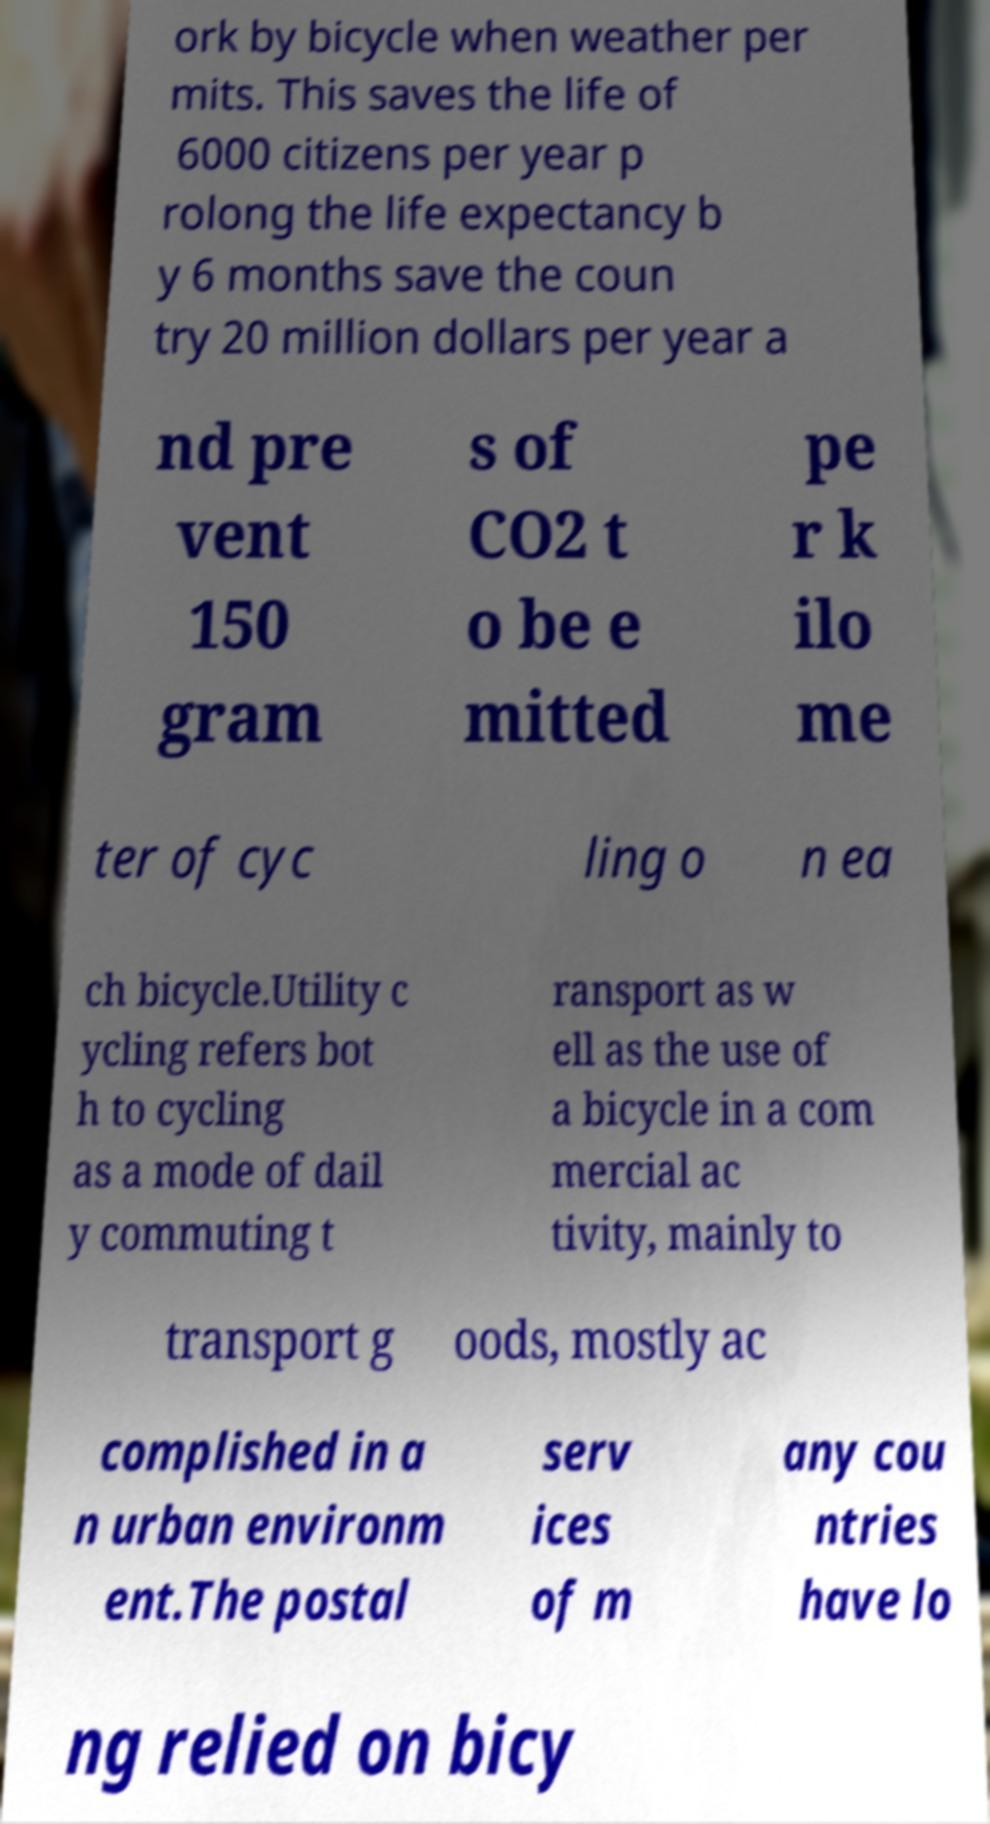Could you assist in decoding the text presented in this image and type it out clearly? ork by bicycle when weather per mits. This saves the life of 6000 citizens per year p rolong the life expectancy b y 6 months save the coun try 20 million dollars per year a nd pre vent 150 gram s of CO2 t o be e mitted pe r k ilo me ter of cyc ling o n ea ch bicycle.Utility c ycling refers bot h to cycling as a mode of dail y commuting t ransport as w ell as the use of a bicycle in a com mercial ac tivity, mainly to transport g oods, mostly ac complished in a n urban environm ent.The postal serv ices of m any cou ntries have lo ng relied on bicy 